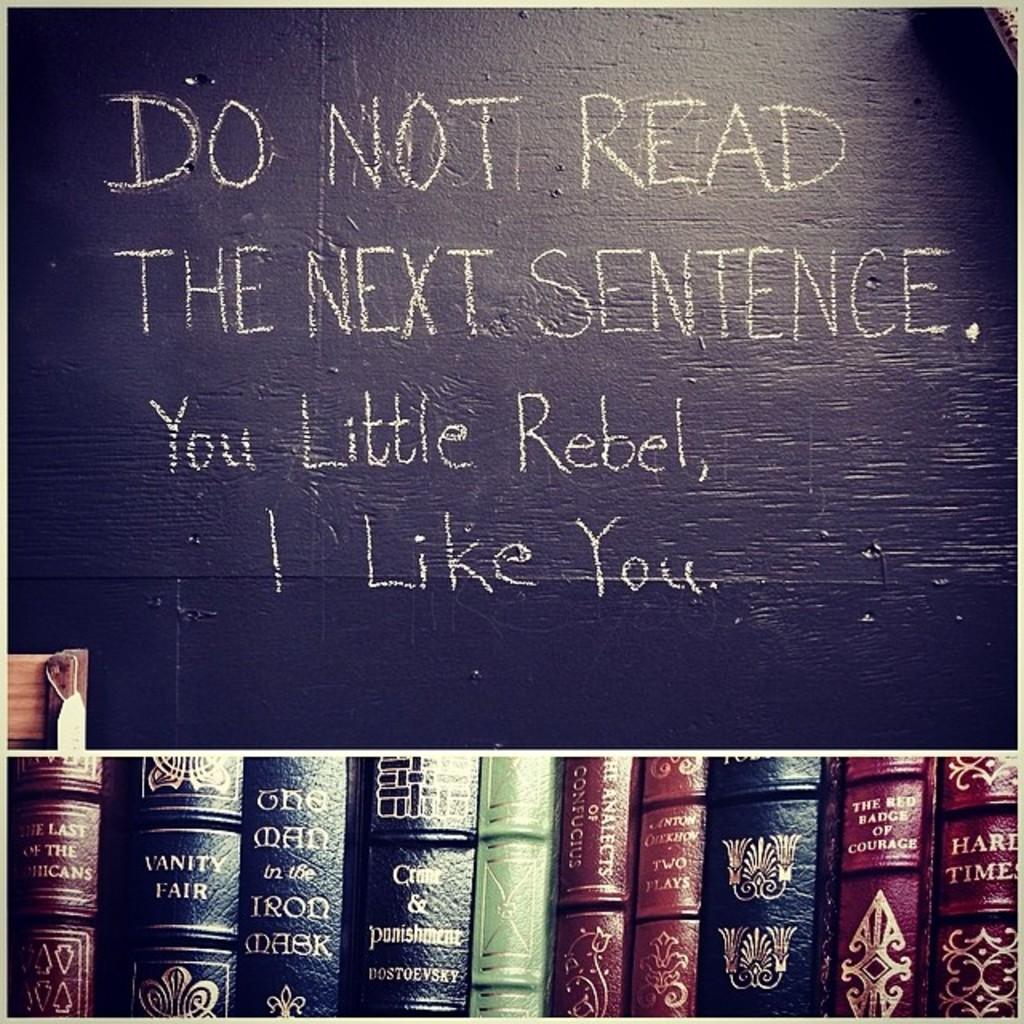What is the text on the last line?
Make the answer very short. I like you. 